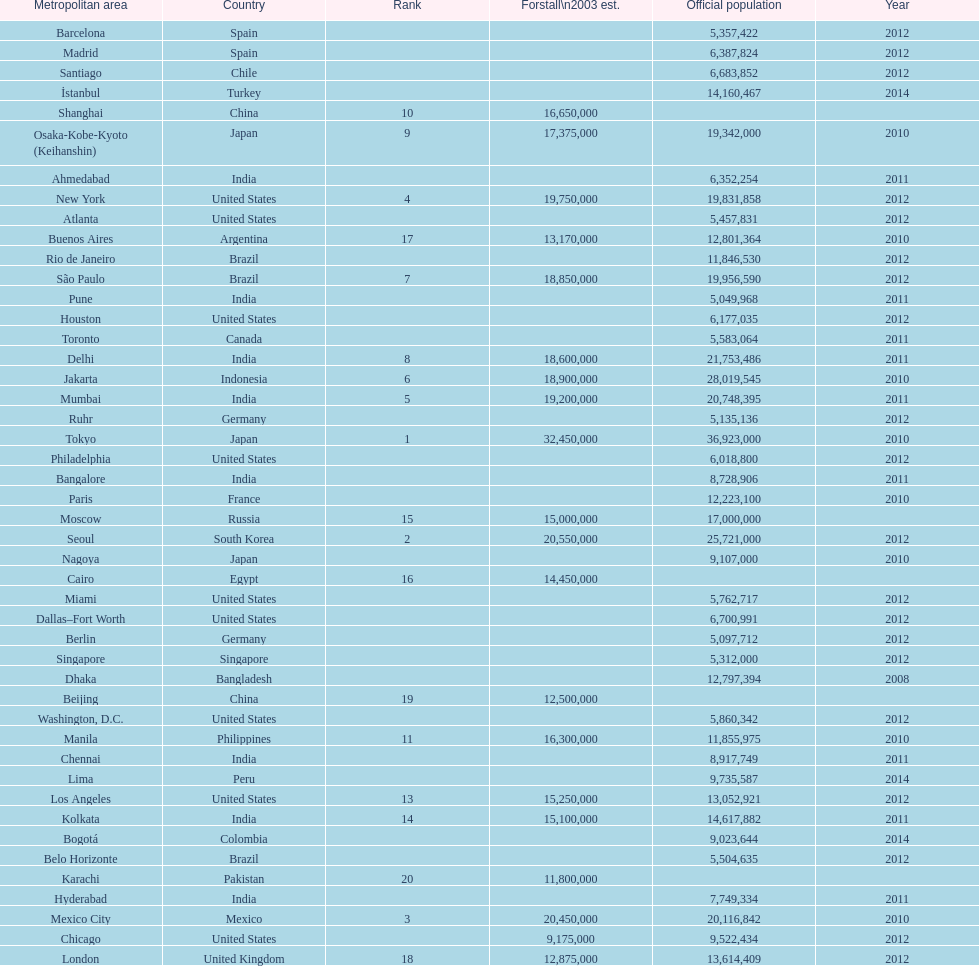Which areas had a population of more than 10,000,000 but less than 20,000,000? Buenos Aires, Dhaka, İstanbul, Kolkata, London, Los Angeles, Manila, Moscow, New York, Osaka-Kobe-Kyoto (Keihanshin), Paris, Rio de Janeiro, São Paulo. 